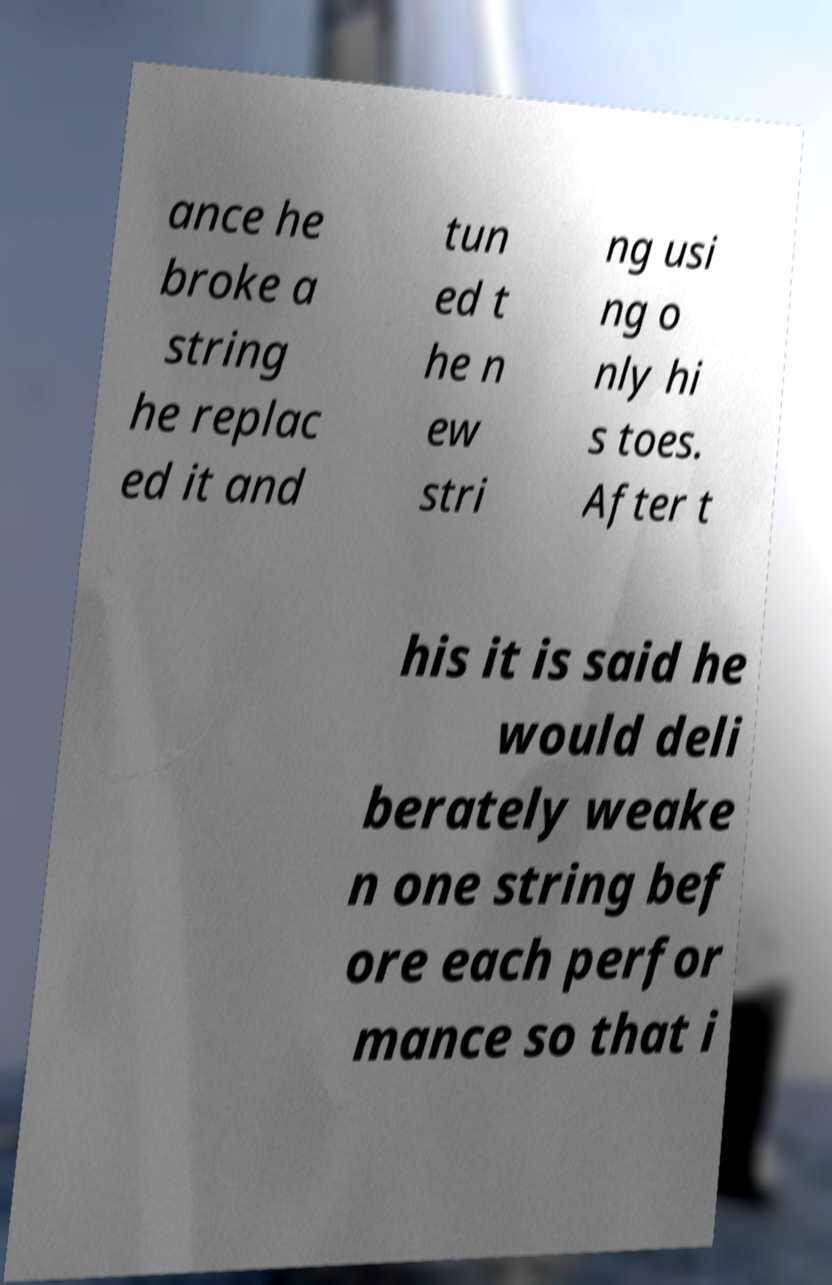Please read and relay the text visible in this image. What does it say? ance he broke a string he replac ed it and tun ed t he n ew stri ng usi ng o nly hi s toes. After t his it is said he would deli berately weake n one string bef ore each perfor mance so that i 